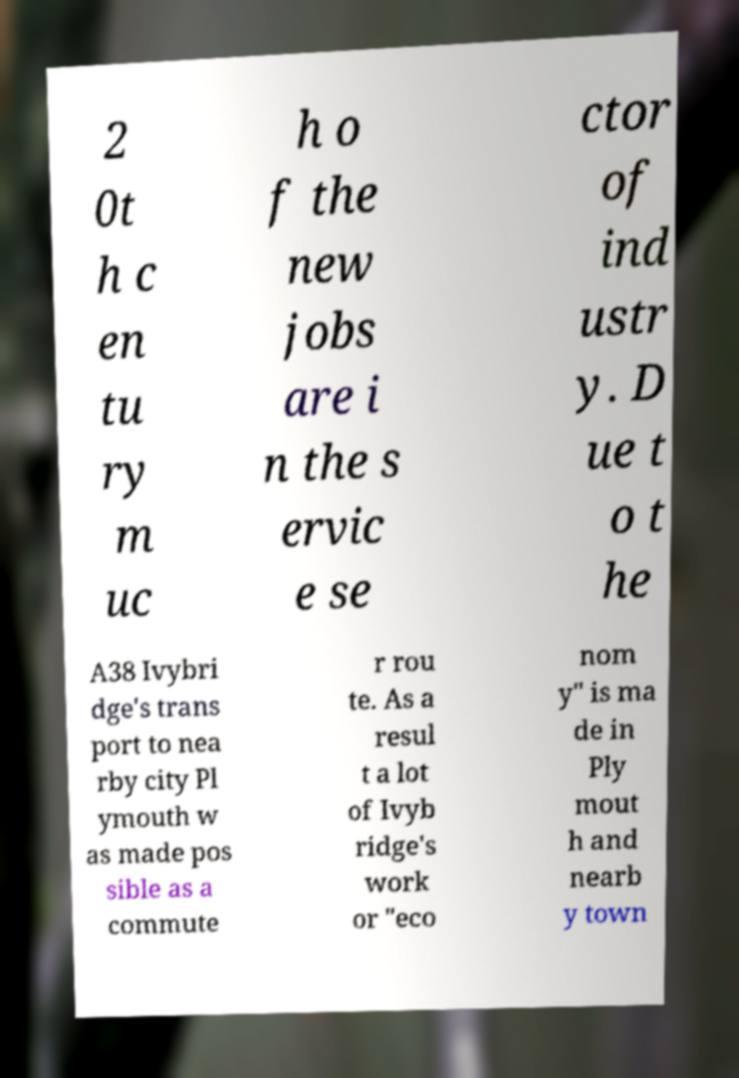Please identify and transcribe the text found in this image. 2 0t h c en tu ry m uc h o f the new jobs are i n the s ervic e se ctor of ind ustr y. D ue t o t he A38 Ivybri dge's trans port to nea rby city Pl ymouth w as made pos sible as a commute r rou te. As a resul t a lot of Ivyb ridge's work or "eco nom y" is ma de in Ply mout h and nearb y town 